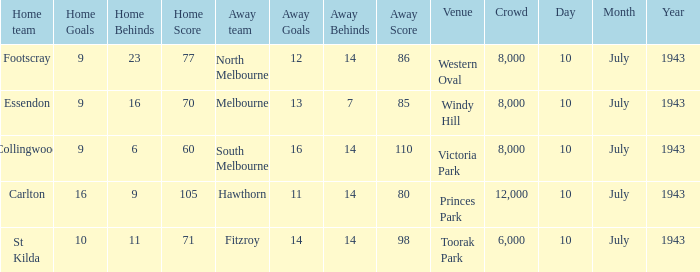When the Home team of carlton played, what was their score? 16.9 (105). 